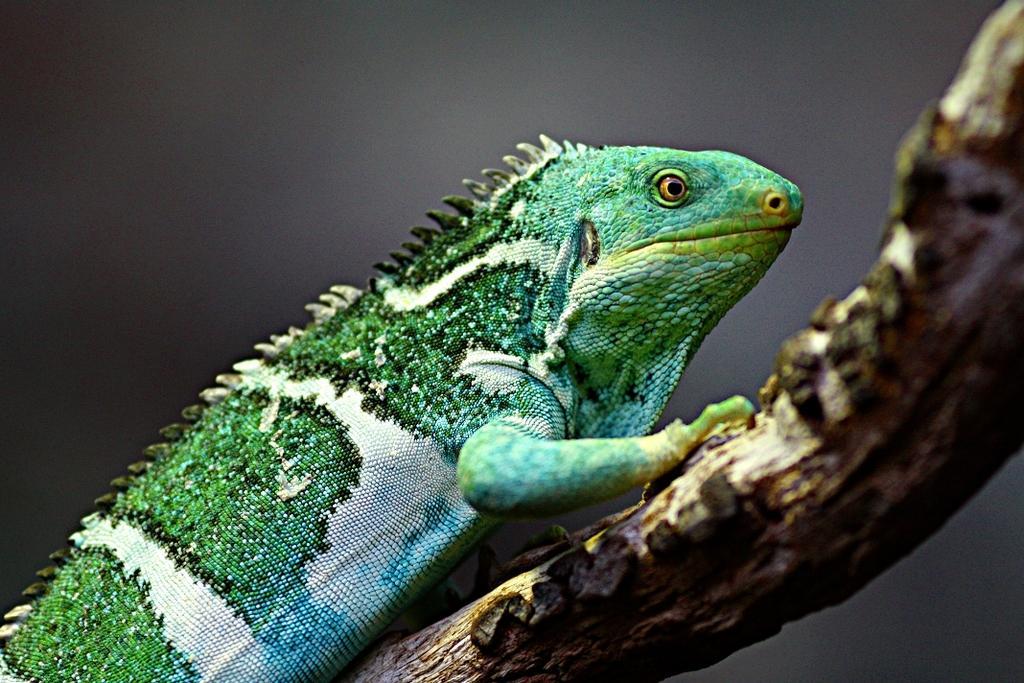Please provide a concise description of this image. In this picture we can see a reptile and blurry background. 